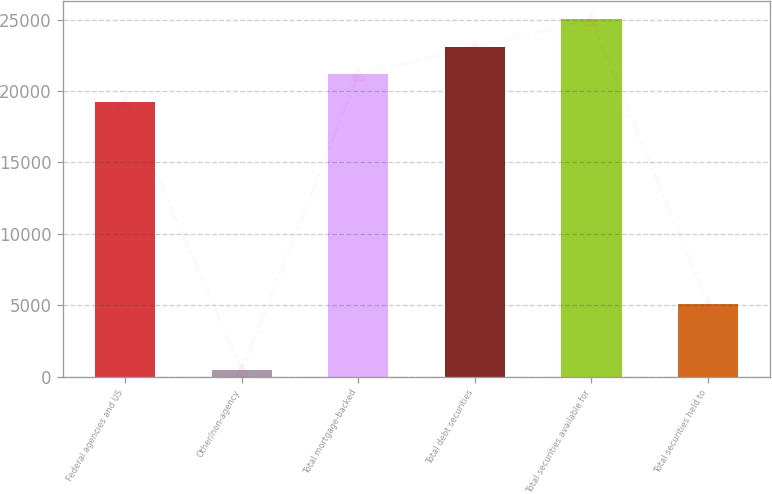Convert chart. <chart><loc_0><loc_0><loc_500><loc_500><bar_chart><fcel>Federal agencies and US<fcel>Other/non-agency<fcel>Total mortgage-backed<fcel>Total debt securities<fcel>Total securities available for<fcel>Total securities held to<nl><fcel>19231<fcel>427<fcel>21159.6<fcel>23088.2<fcel>25016.8<fcel>5071<nl></chart> 